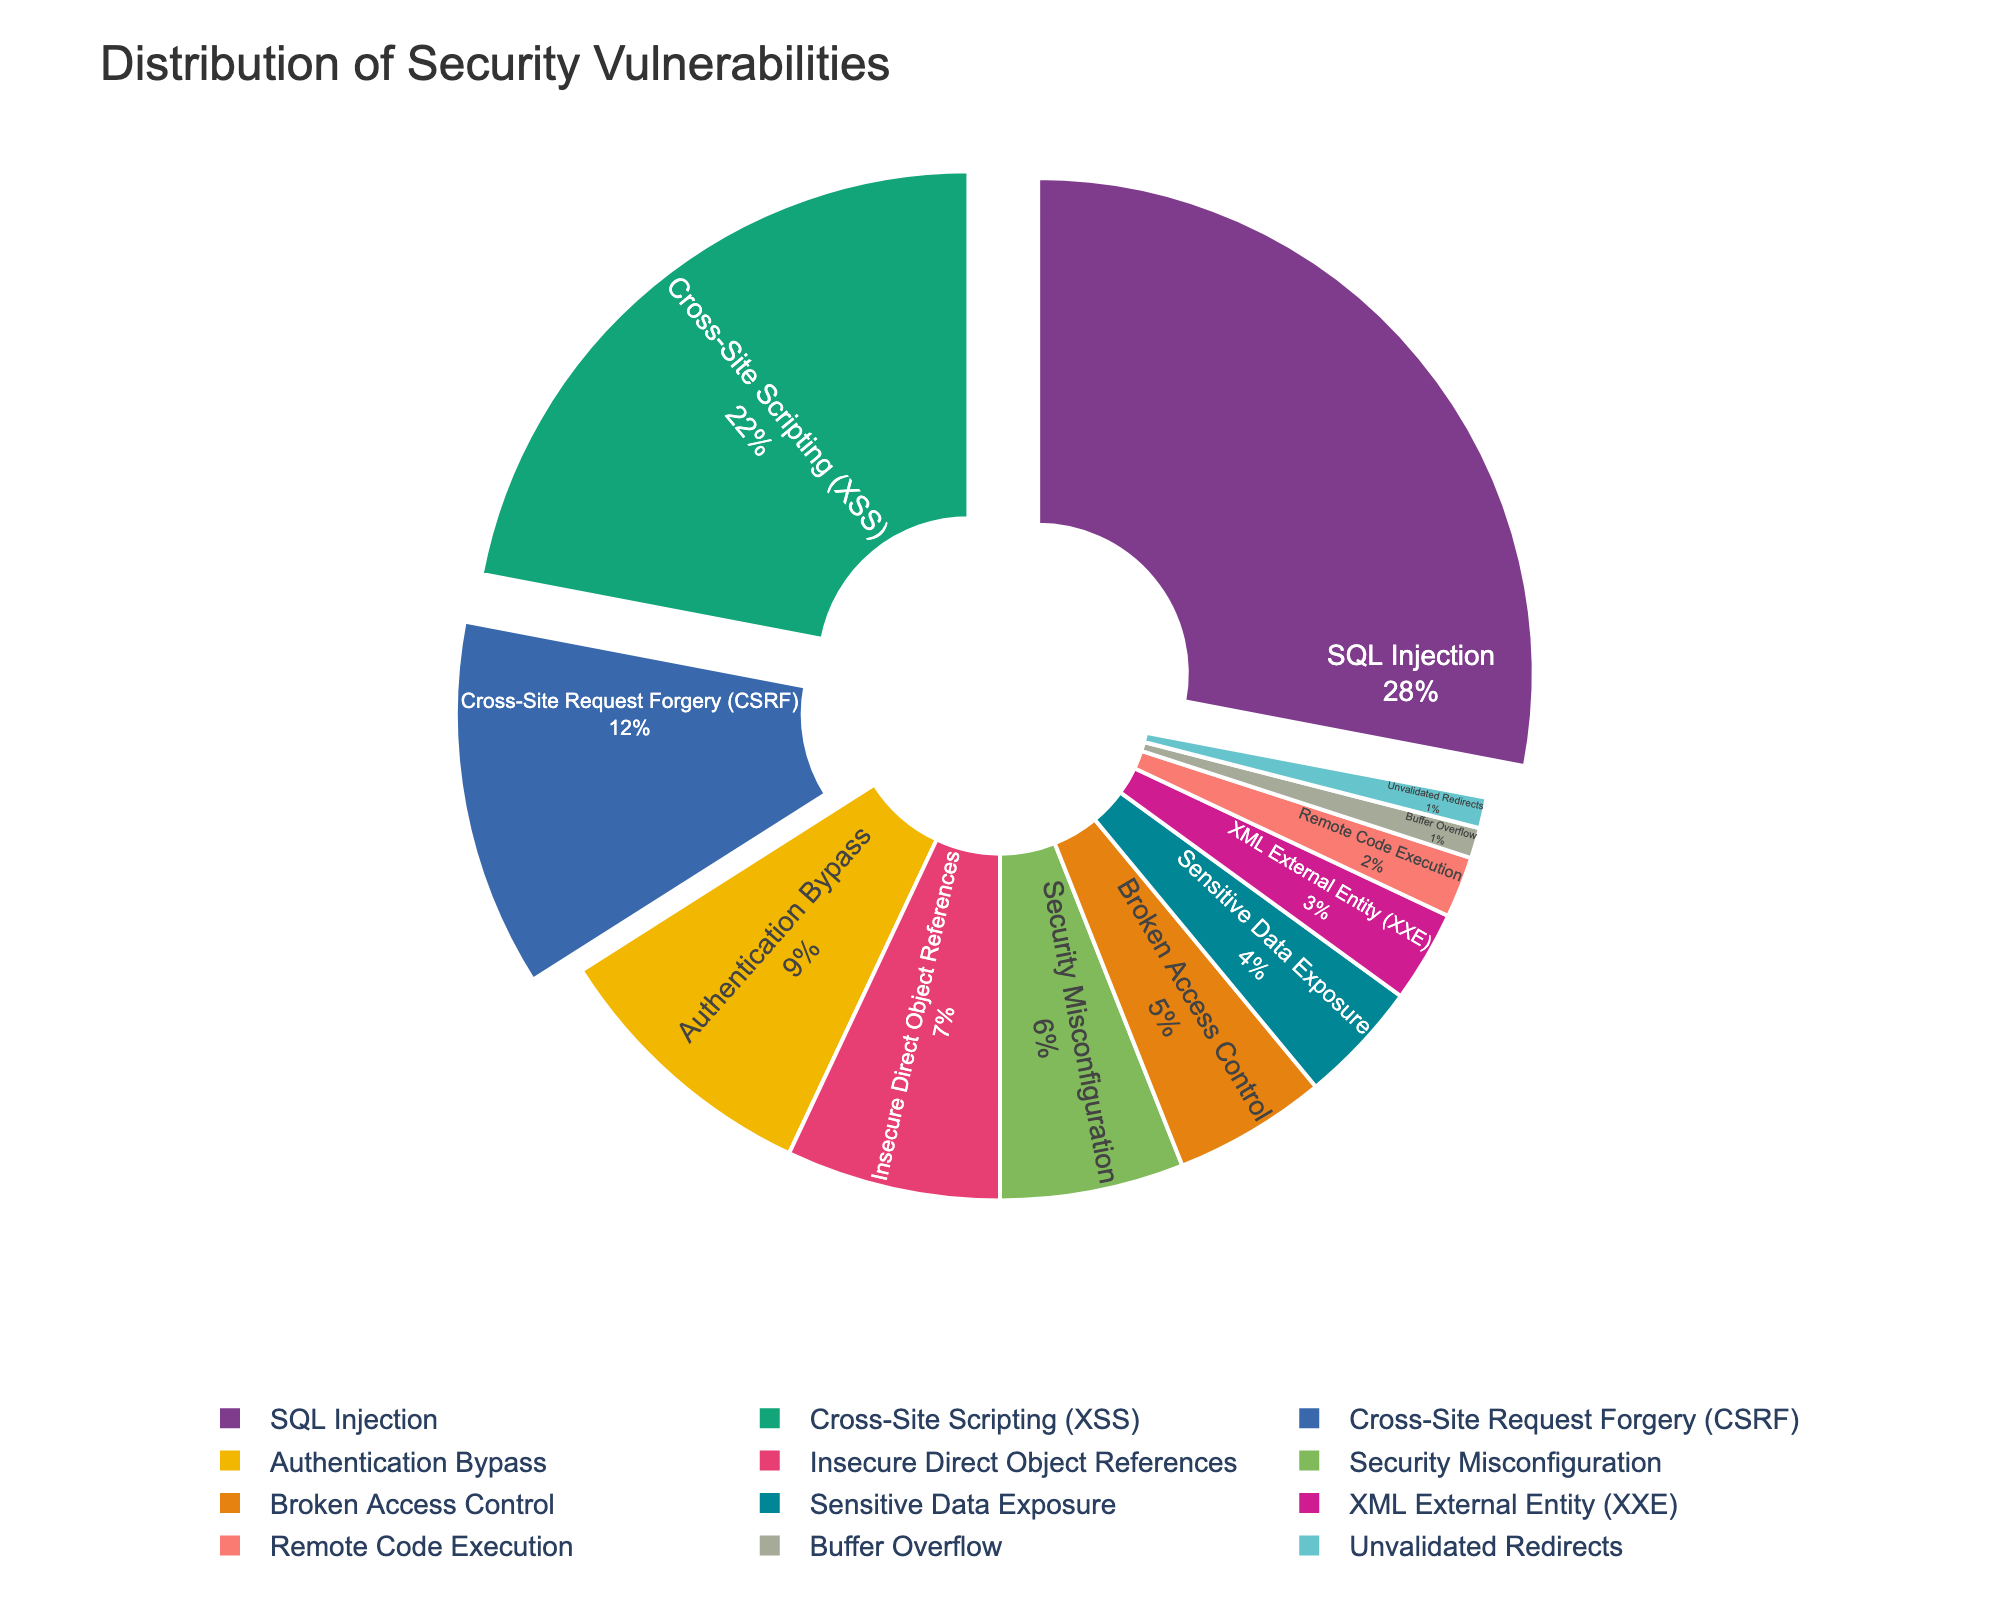What is the most common type of security vulnerability? The most visible or largest segment on the pie chart often represents the most common type. SQL Injection has the largest segment, which means it is the most common type.
Answer: SQL Injection What percentage of vulnerabilities does Cross-Site Scripting (XSS) and CSRF together represent? Add the percentages of XSS (22%) and CSRF (12%) together. That gives 22 + 12 = 34%.
Answer: 34% Which vulnerabilities are represented by a distinct color towards the outer edges? The pie chart segments are colored distinctly and have a slight pull for the top three vulnerabilities. These segments are SQL Injection (28%), Cross-Site Scripting (XSS) (22%), and CSRF (12%).
Answer: SQL Injection, Cross-Site Scripting (XSS), and CSRF What is the combined percentage of vulnerabilities related to access control, including both Broken Access Control and Authentication Bypass? Add the percentages for Broken Access Control (5%) and Authentication Bypass (9%). That gives 5 + 9 = 14%.
Answer: 14% Which vulnerability type has twice the percentage of Unvalidated Redirects? Unvalidated Redirects have 1%. Buffer Overflow has 1% too, which is equal. The next higher segment is Remote Code Execution with 2%, which is twice the percentage of Unvalidated Redirects.
Answer: Remote Code Execution How does the percentage of Insecure Direct Object References compare to Security Misconfiguration? Insecure Direct Object References have 7%, and Security Misconfiguration has 6%. 7% is greater than 6%.
Answer: More than What is the total percentage of the least common vulnerabilities combined (Buffer Overflow and Unvalidated Redirects)? Add the percentages for Buffer Overflow (1%) and Unvalidated Redirects (1%). This gives 1 + 1 = 2%.
Answer: 2% What percentage is represented by vulnerabilities related to sensitive data? Sensitive Data Exposure alone represents 4%, as per the data in the figure.
Answer: 4% What is the difference in percentages between Cross-Site Scripting (XSS) and Authentication Bypass? Subtract the percentage of Authentication Bypass (9%) from Cross-Site Scripting (22%). That gives 22 - 9 = 13%.
Answer: 13% Which vulnerabilities have single-digit percentages? Vulnerabilities with the second smallest segments: Authentication Bypass (9%), Insecure Direct Object References (7%), Security Misconfiguration (6%), Broken Access Control (5%), and Sensitive Data Exposure (4%).
Answer: Authentication Bypass, Insecure Direct Object References, Security Misconfiguration, Broken Access Control, Sensitive Data Exposure 